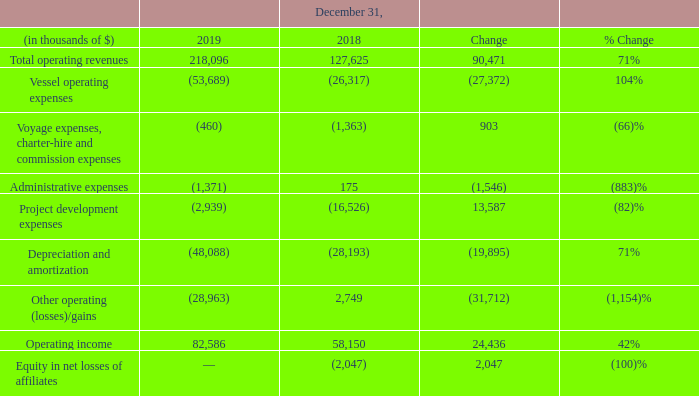FLNG segment
Total operating revenues: On May 31, 2018, the Hilli was accepted by the customer and, accordingly, commenced operations. The Hilli generated $218.1 million of total operating revenues, as a result of a full year of operations during 2019, in relation to her liquefaction services, compared to $127.6 million in 2018.
Vessel operating expenses: The Hilli incurred $53.7 million of vessel operating expenses for the year ended December 31, 2019, as a result of a full year of operations in 2019, compared to $26.3 million in 2018 following commencement of operations on May 31, 2018.
Voyage, charterhire and commission expenses: The decrease in voyage, charterhire and commission expenses of $0.9 million to $0.5 million for the year ended December 31, 2019 compared to $1.4 million in 2018, is due to lower bunker consumption as a result of the Hilli undergoing commissioning in preparation for her commercial readiness in 2018.
Administrative expenses: Administrative expenses increased by $1.5 million to $1.4 million for the year ended December 31, 2019 compared to a credit $0.2 million in 2018, principally due to an increase in corporate expenses, salaries and employee benefits following the full year of operation of the Hilli, compared to seven months in 2018.
Project development expenses: This relates to non-capitalized project-related expenses comprising of legal, professional and consultancy costs. The decrease was due to the commencement of capitalization of engineering consultation fees in relation to the Gimi GTA Project following the Gimi entering Keppel's shipyard for her conversion into a FLNG in December 2018.
Depreciation and amortization: Following the Hilli's commencement of operations on May 31, 2018, depreciation and amortization of the vessel was recognized. A full year of depreciation was recognized for the year ended December 31, 2019 compared to the seven months of depreciation in 2018.
Other operating (losses)/gains: Included in other operating (losses)/gains are: • realized gain on the oil derivative instrument, based on monthly billings above the base tolling fee under the LTA of $13.1 million for the year ended December 31, 2019 compared to $26.7 million in 2018; • unrealized loss on the oil derivative instrument, due to changes in oil prices above a contractual floor price over term of the LTA of $39.1 million for the year ended December 31, 2019 compared to unrealized loss of $10.0 million in 2018; and • write-off of $3.0 million and $12.7 million of unrecoverable receivables relating to OneLNG for the year ended December 31, 2019 and 2018, respectively.
Equity in net losses of affiliates: In April 2018, we and Schlumberger decided to wind down OneLNG and work on FLNG projects on a case-by-case basis.
How much unrecoverable receivables was written off in 2018 relating to OneLNG? $12.7 million. How many months of depreciation was recognized in 2018? Seven months. What are the different components of expenses? Vessel operating expenses, voyage expenses, charter-hire and commission expenses, administrative expenses, project development expenses, depreciation and amortization, other operating (losses)/gains. In which year has a higher project development expense? (16,526) > (2,939)
Answer: 2018. What was the change in total operating revenues?
Answer scale should be: thousand. 218,096 - 127,625 
Answer: 90471. What was the percentage change in operating income?
Answer scale should be: percent. (82,586 - 58,150)/58,150 
Answer: 42.02. 